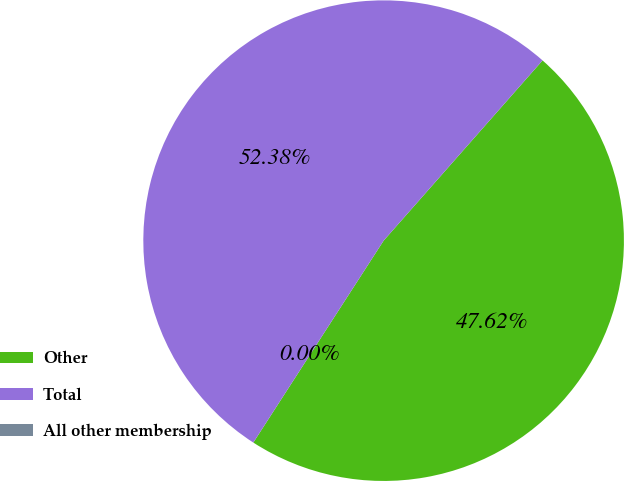<chart> <loc_0><loc_0><loc_500><loc_500><pie_chart><fcel>Other<fcel>Total<fcel>All other membership<nl><fcel>47.62%<fcel>52.38%<fcel>0.0%<nl></chart> 